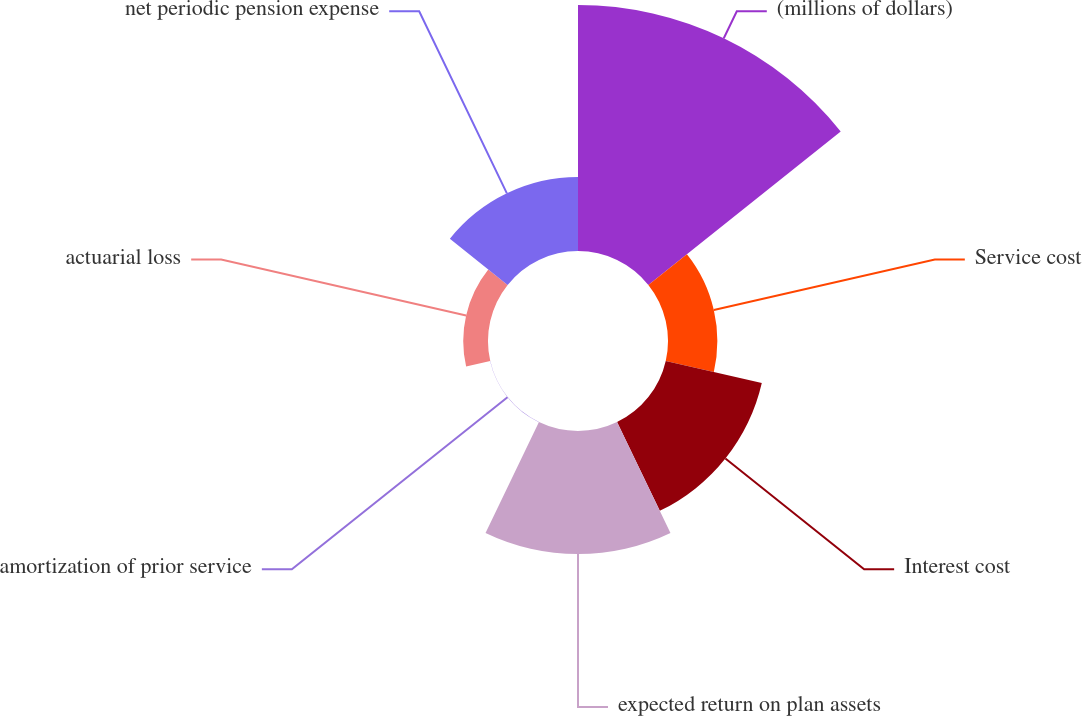Convert chart to OTSL. <chart><loc_0><loc_0><loc_500><loc_500><pie_chart><fcel>(millions of dollars)<fcel>Service cost<fcel>Interest cost<fcel>expected return on plan assets<fcel>amortization of prior service<fcel>actuarial loss<fcel>net periodic pension expense<nl><fcel>39.95%<fcel>8.01%<fcel>16.0%<fcel>19.99%<fcel>0.03%<fcel>4.02%<fcel>12.0%<nl></chart> 